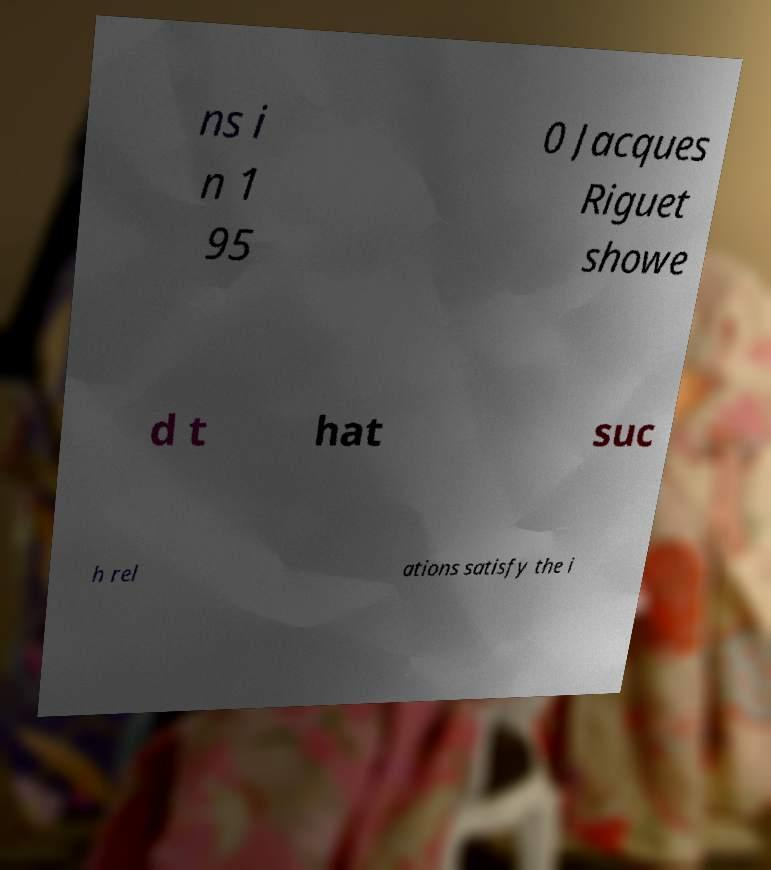Could you assist in decoding the text presented in this image and type it out clearly? ns i n 1 95 0 Jacques Riguet showe d t hat suc h rel ations satisfy the i 